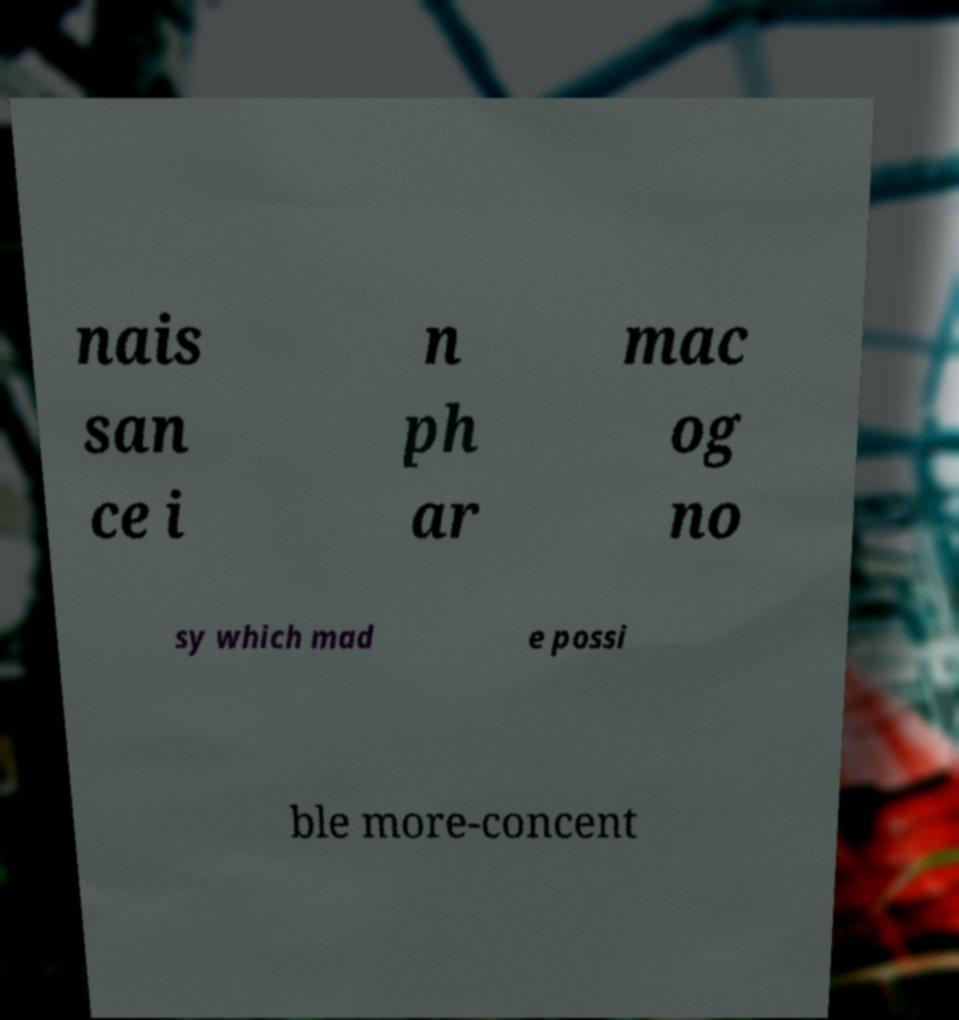What messages or text are displayed in this image? I need them in a readable, typed format. nais san ce i n ph ar mac og no sy which mad e possi ble more-concent 